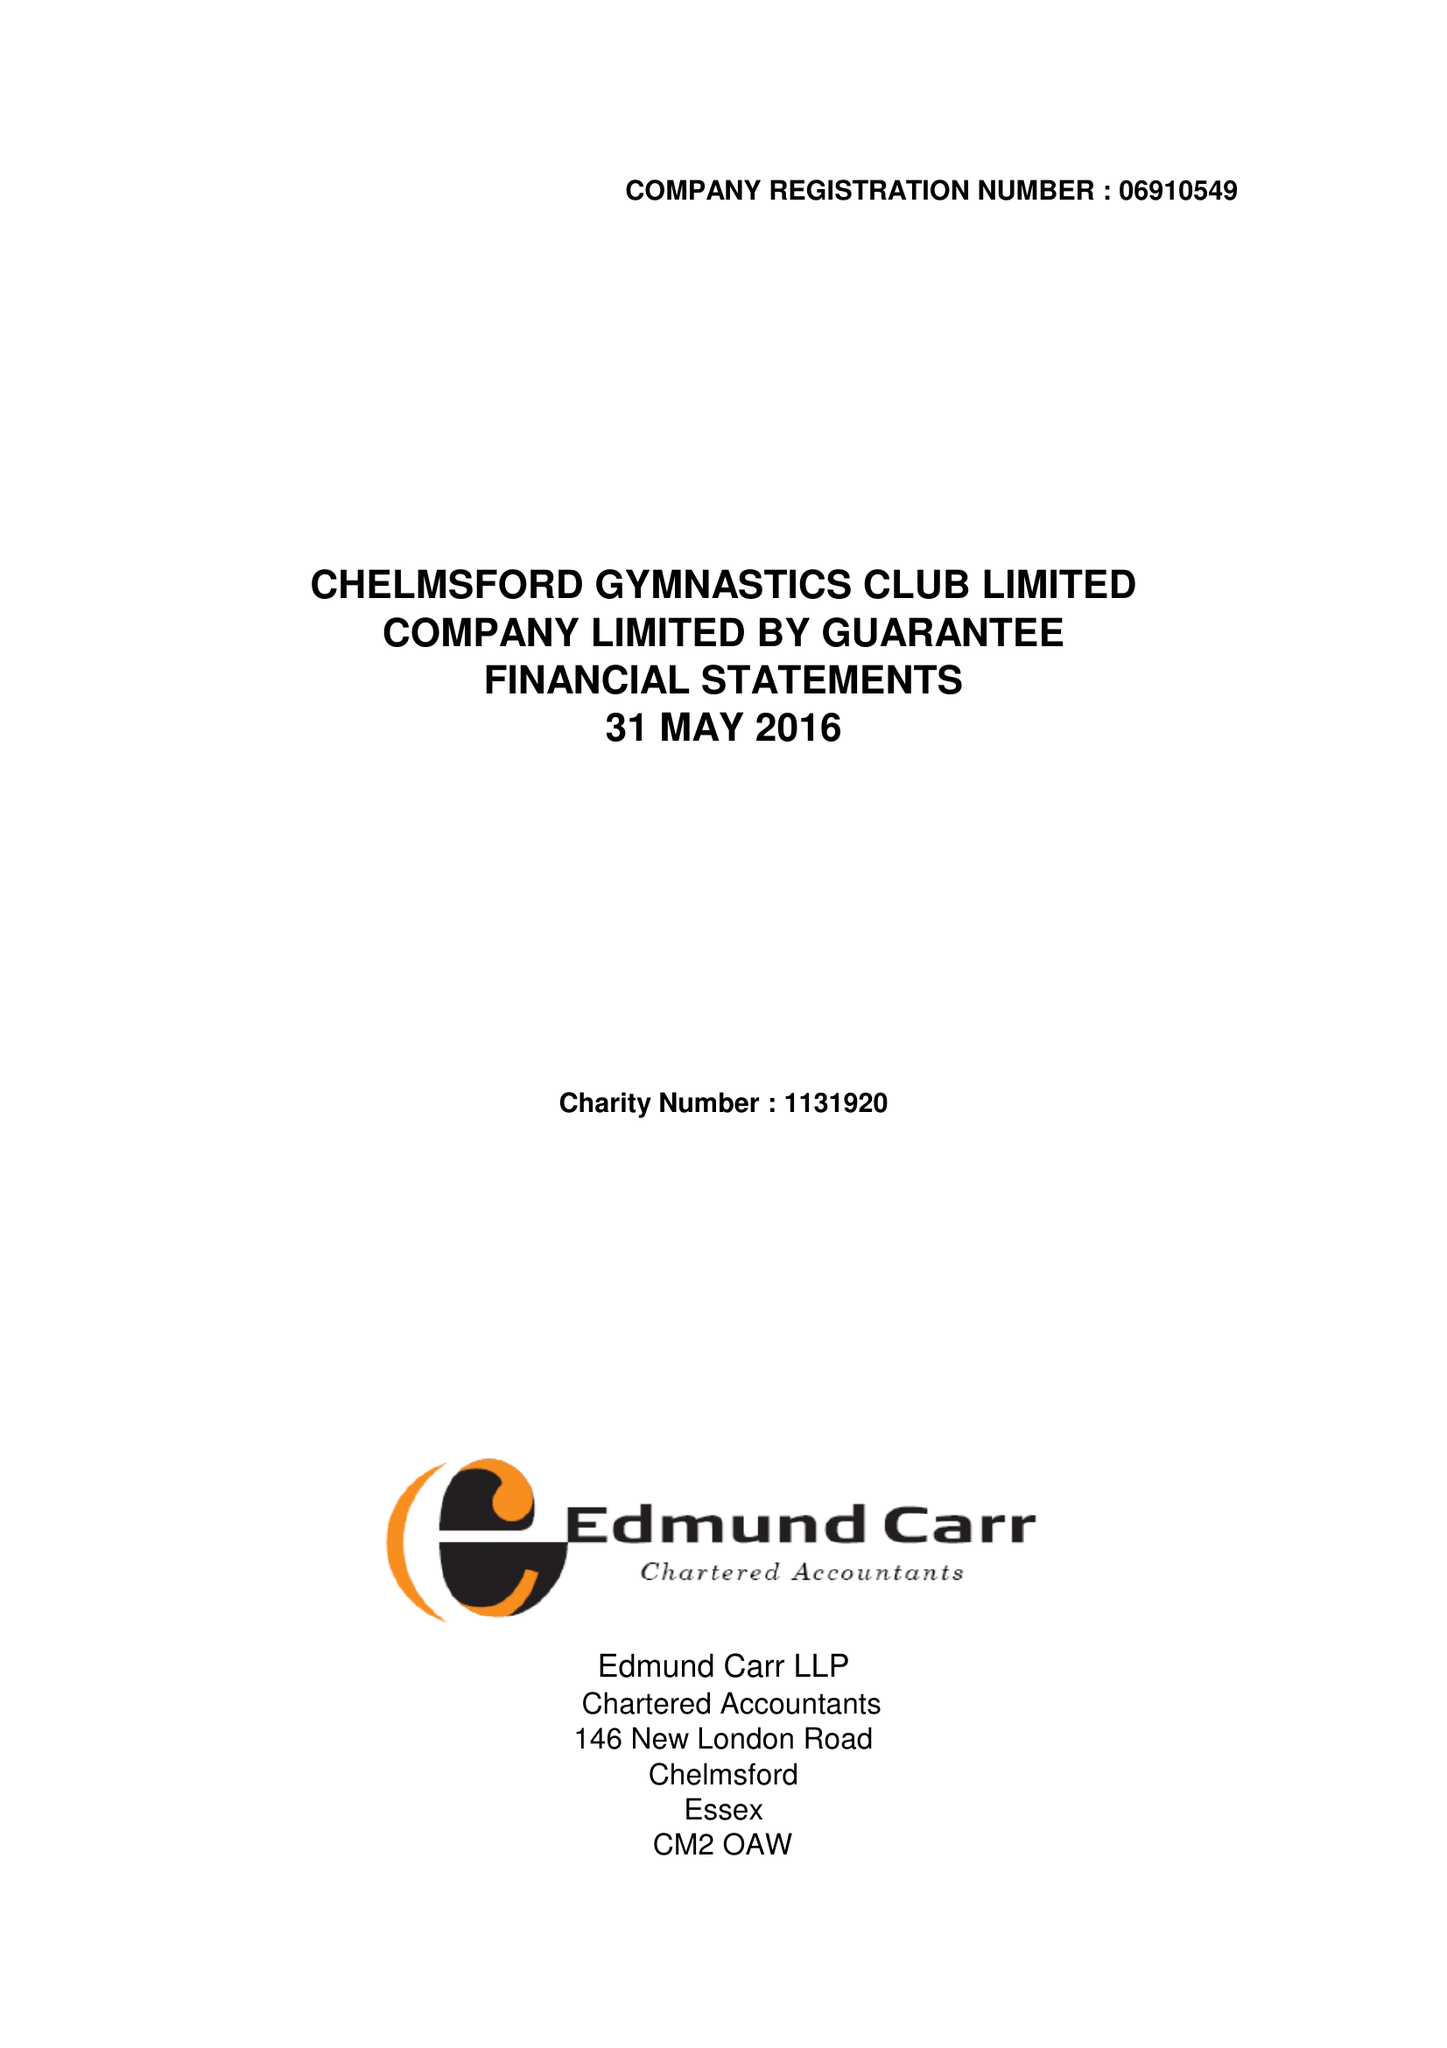What is the value for the income_annually_in_british_pounds?
Answer the question using a single word or phrase. 421736.00 